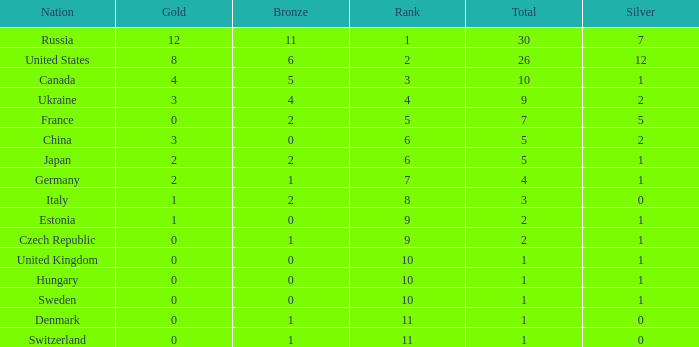How many silvers have a Nation of hungary, and a Rank larger than 10? 0.0. 